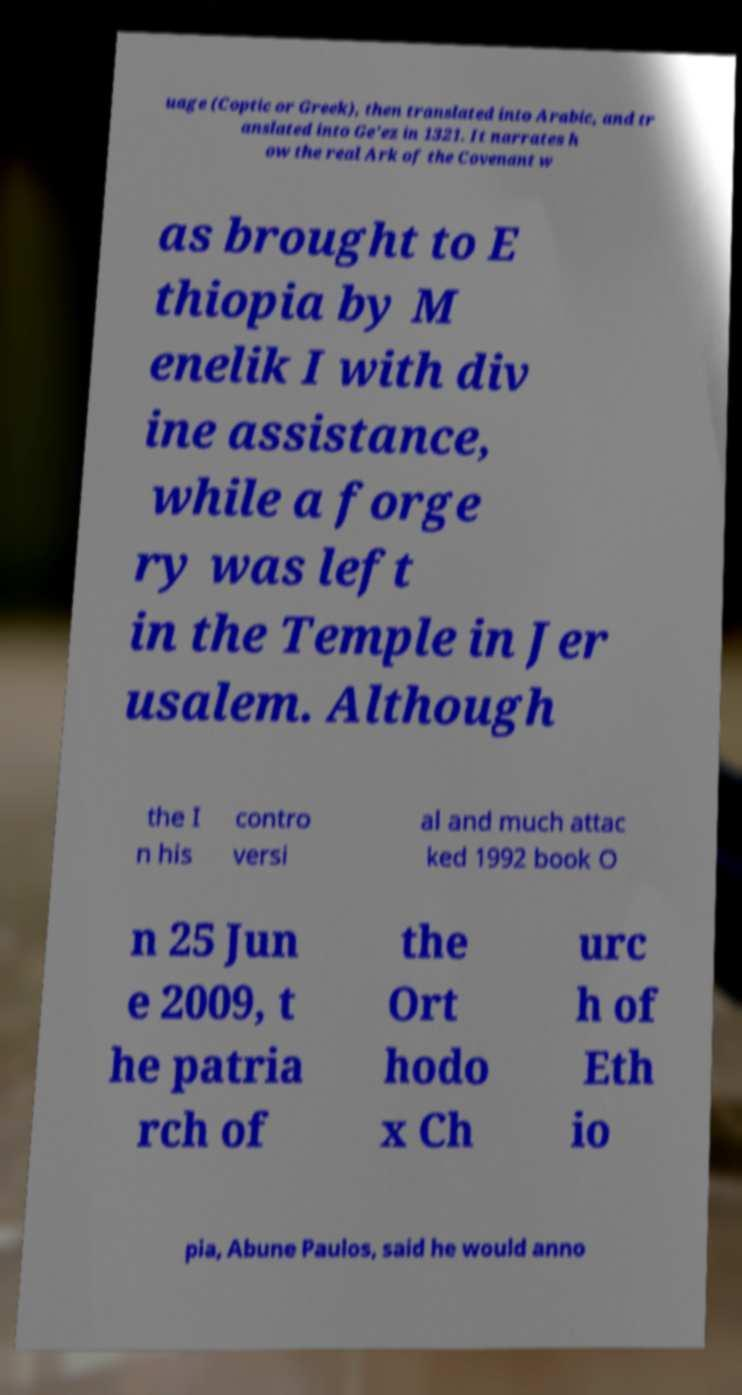What messages or text are displayed in this image? I need them in a readable, typed format. uage (Coptic or Greek), then translated into Arabic, and tr anslated into Ge'ez in 1321. It narrates h ow the real Ark of the Covenant w as brought to E thiopia by M enelik I with div ine assistance, while a forge ry was left in the Temple in Jer usalem. Although the I n his contro versi al and much attac ked 1992 book O n 25 Jun e 2009, t he patria rch of the Ort hodo x Ch urc h of Eth io pia, Abune Paulos, said he would anno 